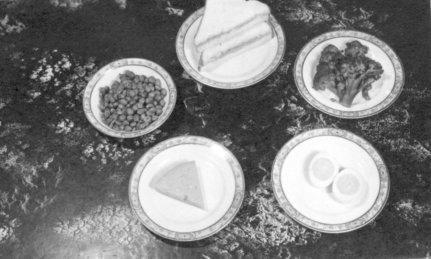How many dishes are shown?
Give a very brief answer. 5. How many cakes are there?
Give a very brief answer. 1. How many bowls are in the picture?
Give a very brief answer. 3. 